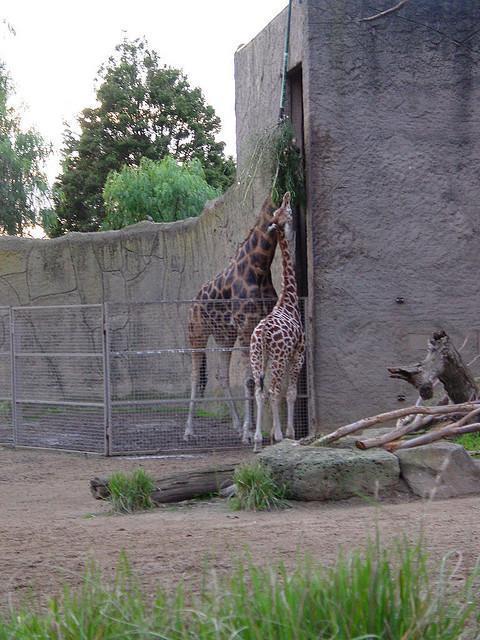How many giraffes are in the picture?
Give a very brief answer. 2. 